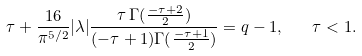Convert formula to latex. <formula><loc_0><loc_0><loc_500><loc_500>\tau + \frac { 1 6 } { \pi ^ { 5 / 2 } } | \lambda | \frac { \tau \, \Gamma ( \frac { - \tau + 2 } { 2 } ) } { ( - \tau + 1 ) \Gamma ( \frac { - \tau + 1 } { 2 } ) } = q - 1 , \quad \tau < 1 .</formula> 